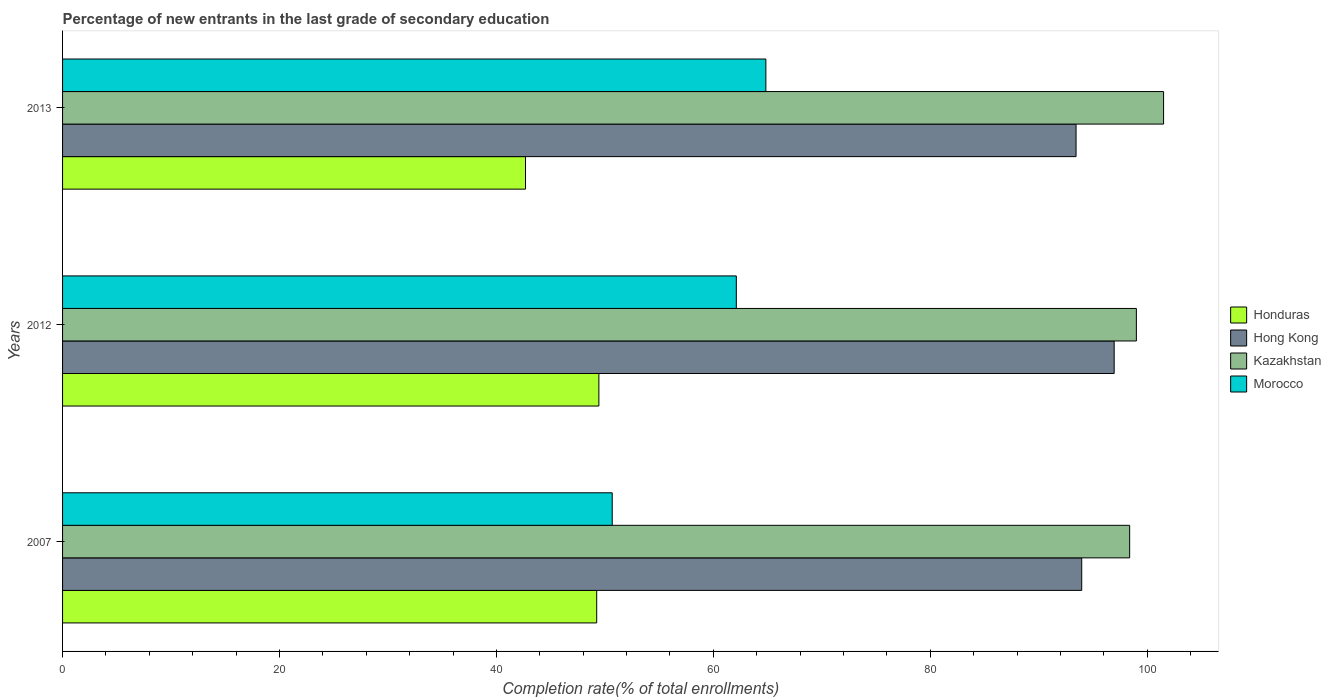How many groups of bars are there?
Your answer should be compact. 3. How many bars are there on the 3rd tick from the top?
Ensure brevity in your answer.  4. How many bars are there on the 1st tick from the bottom?
Your response must be concise. 4. In how many cases, is the number of bars for a given year not equal to the number of legend labels?
Your answer should be very brief. 0. What is the percentage of new entrants in Honduras in 2012?
Offer a terse response. 49.45. Across all years, what is the maximum percentage of new entrants in Hong Kong?
Give a very brief answer. 96.95. Across all years, what is the minimum percentage of new entrants in Morocco?
Ensure brevity in your answer.  50.67. In which year was the percentage of new entrants in Honduras maximum?
Provide a succinct answer. 2012. In which year was the percentage of new entrants in Honduras minimum?
Provide a short and direct response. 2013. What is the total percentage of new entrants in Kazakhstan in the graph?
Provide a succinct answer. 298.89. What is the difference between the percentage of new entrants in Honduras in 2007 and that in 2013?
Your answer should be compact. 6.56. What is the difference between the percentage of new entrants in Morocco in 2013 and the percentage of new entrants in Hong Kong in 2012?
Your response must be concise. -32.11. What is the average percentage of new entrants in Morocco per year?
Your response must be concise. 59.21. In the year 2012, what is the difference between the percentage of new entrants in Honduras and percentage of new entrants in Hong Kong?
Make the answer very short. -47.51. In how many years, is the percentage of new entrants in Morocco greater than 84 %?
Provide a short and direct response. 0. What is the ratio of the percentage of new entrants in Honduras in 2007 to that in 2013?
Give a very brief answer. 1.15. Is the difference between the percentage of new entrants in Honduras in 2012 and 2013 greater than the difference between the percentage of new entrants in Hong Kong in 2012 and 2013?
Ensure brevity in your answer.  Yes. What is the difference between the highest and the second highest percentage of new entrants in Hong Kong?
Provide a short and direct response. 2.99. What is the difference between the highest and the lowest percentage of new entrants in Honduras?
Make the answer very short. 6.77. In how many years, is the percentage of new entrants in Morocco greater than the average percentage of new entrants in Morocco taken over all years?
Ensure brevity in your answer.  2. Is the sum of the percentage of new entrants in Hong Kong in 2007 and 2013 greater than the maximum percentage of new entrants in Honduras across all years?
Keep it short and to the point. Yes. What does the 1st bar from the top in 2013 represents?
Your response must be concise. Morocco. What does the 4th bar from the bottom in 2013 represents?
Keep it short and to the point. Morocco. Is it the case that in every year, the sum of the percentage of new entrants in Hong Kong and percentage of new entrants in Morocco is greater than the percentage of new entrants in Honduras?
Offer a very short reply. Yes. How many years are there in the graph?
Your response must be concise. 3. What is the difference between two consecutive major ticks on the X-axis?
Provide a succinct answer. 20. Are the values on the major ticks of X-axis written in scientific E-notation?
Provide a short and direct response. No. Does the graph contain any zero values?
Provide a succinct answer. No. Where does the legend appear in the graph?
Offer a very short reply. Center right. How many legend labels are there?
Make the answer very short. 4. How are the legend labels stacked?
Your answer should be very brief. Vertical. What is the title of the graph?
Provide a succinct answer. Percentage of new entrants in the last grade of secondary education. What is the label or title of the X-axis?
Ensure brevity in your answer.  Completion rate(% of total enrollments). What is the label or title of the Y-axis?
Keep it short and to the point. Years. What is the Completion rate(% of total enrollments) in Honduras in 2007?
Offer a terse response. 49.24. What is the Completion rate(% of total enrollments) of Hong Kong in 2007?
Your response must be concise. 93.96. What is the Completion rate(% of total enrollments) in Kazakhstan in 2007?
Your response must be concise. 98.38. What is the Completion rate(% of total enrollments) of Morocco in 2007?
Your response must be concise. 50.67. What is the Completion rate(% of total enrollments) of Honduras in 2012?
Offer a terse response. 49.45. What is the Completion rate(% of total enrollments) in Hong Kong in 2012?
Provide a succinct answer. 96.95. What is the Completion rate(% of total enrollments) of Kazakhstan in 2012?
Offer a terse response. 99. What is the Completion rate(% of total enrollments) of Morocco in 2012?
Keep it short and to the point. 62.12. What is the Completion rate(% of total enrollments) in Honduras in 2013?
Offer a very short reply. 42.68. What is the Completion rate(% of total enrollments) of Hong Kong in 2013?
Provide a succinct answer. 93.44. What is the Completion rate(% of total enrollments) of Kazakhstan in 2013?
Make the answer very short. 101.51. What is the Completion rate(% of total enrollments) of Morocco in 2013?
Offer a very short reply. 64.84. Across all years, what is the maximum Completion rate(% of total enrollments) in Honduras?
Your response must be concise. 49.45. Across all years, what is the maximum Completion rate(% of total enrollments) in Hong Kong?
Make the answer very short. 96.95. Across all years, what is the maximum Completion rate(% of total enrollments) of Kazakhstan?
Provide a succinct answer. 101.51. Across all years, what is the maximum Completion rate(% of total enrollments) of Morocco?
Keep it short and to the point. 64.84. Across all years, what is the minimum Completion rate(% of total enrollments) in Honduras?
Offer a terse response. 42.68. Across all years, what is the minimum Completion rate(% of total enrollments) of Hong Kong?
Offer a very short reply. 93.44. Across all years, what is the minimum Completion rate(% of total enrollments) of Kazakhstan?
Give a very brief answer. 98.38. Across all years, what is the minimum Completion rate(% of total enrollments) in Morocco?
Offer a terse response. 50.67. What is the total Completion rate(% of total enrollments) of Honduras in the graph?
Your answer should be compact. 141.37. What is the total Completion rate(% of total enrollments) of Hong Kong in the graph?
Ensure brevity in your answer.  284.35. What is the total Completion rate(% of total enrollments) in Kazakhstan in the graph?
Give a very brief answer. 298.89. What is the total Completion rate(% of total enrollments) of Morocco in the graph?
Your answer should be compact. 177.63. What is the difference between the Completion rate(% of total enrollments) in Honduras in 2007 and that in 2012?
Give a very brief answer. -0.2. What is the difference between the Completion rate(% of total enrollments) in Hong Kong in 2007 and that in 2012?
Provide a short and direct response. -2.99. What is the difference between the Completion rate(% of total enrollments) of Kazakhstan in 2007 and that in 2012?
Make the answer very short. -0.62. What is the difference between the Completion rate(% of total enrollments) in Morocco in 2007 and that in 2012?
Offer a terse response. -11.44. What is the difference between the Completion rate(% of total enrollments) in Honduras in 2007 and that in 2013?
Your response must be concise. 6.56. What is the difference between the Completion rate(% of total enrollments) in Hong Kong in 2007 and that in 2013?
Your answer should be compact. 0.52. What is the difference between the Completion rate(% of total enrollments) of Kazakhstan in 2007 and that in 2013?
Your response must be concise. -3.13. What is the difference between the Completion rate(% of total enrollments) of Morocco in 2007 and that in 2013?
Offer a terse response. -14.17. What is the difference between the Completion rate(% of total enrollments) in Honduras in 2012 and that in 2013?
Your answer should be compact. 6.77. What is the difference between the Completion rate(% of total enrollments) in Hong Kong in 2012 and that in 2013?
Ensure brevity in your answer.  3.51. What is the difference between the Completion rate(% of total enrollments) in Kazakhstan in 2012 and that in 2013?
Your response must be concise. -2.51. What is the difference between the Completion rate(% of total enrollments) of Morocco in 2012 and that in 2013?
Make the answer very short. -2.73. What is the difference between the Completion rate(% of total enrollments) in Honduras in 2007 and the Completion rate(% of total enrollments) in Hong Kong in 2012?
Keep it short and to the point. -47.71. What is the difference between the Completion rate(% of total enrollments) of Honduras in 2007 and the Completion rate(% of total enrollments) of Kazakhstan in 2012?
Your answer should be very brief. -49.76. What is the difference between the Completion rate(% of total enrollments) in Honduras in 2007 and the Completion rate(% of total enrollments) in Morocco in 2012?
Your answer should be very brief. -12.87. What is the difference between the Completion rate(% of total enrollments) of Hong Kong in 2007 and the Completion rate(% of total enrollments) of Kazakhstan in 2012?
Ensure brevity in your answer.  -5.04. What is the difference between the Completion rate(% of total enrollments) of Hong Kong in 2007 and the Completion rate(% of total enrollments) of Morocco in 2012?
Offer a terse response. 31.84. What is the difference between the Completion rate(% of total enrollments) of Kazakhstan in 2007 and the Completion rate(% of total enrollments) of Morocco in 2012?
Provide a short and direct response. 36.26. What is the difference between the Completion rate(% of total enrollments) of Honduras in 2007 and the Completion rate(% of total enrollments) of Hong Kong in 2013?
Offer a very short reply. -44.19. What is the difference between the Completion rate(% of total enrollments) in Honduras in 2007 and the Completion rate(% of total enrollments) in Kazakhstan in 2013?
Provide a short and direct response. -52.26. What is the difference between the Completion rate(% of total enrollments) of Honduras in 2007 and the Completion rate(% of total enrollments) of Morocco in 2013?
Keep it short and to the point. -15.6. What is the difference between the Completion rate(% of total enrollments) of Hong Kong in 2007 and the Completion rate(% of total enrollments) of Kazakhstan in 2013?
Your response must be concise. -7.55. What is the difference between the Completion rate(% of total enrollments) in Hong Kong in 2007 and the Completion rate(% of total enrollments) in Morocco in 2013?
Give a very brief answer. 29.12. What is the difference between the Completion rate(% of total enrollments) in Kazakhstan in 2007 and the Completion rate(% of total enrollments) in Morocco in 2013?
Your answer should be compact. 33.54. What is the difference between the Completion rate(% of total enrollments) of Honduras in 2012 and the Completion rate(% of total enrollments) of Hong Kong in 2013?
Provide a succinct answer. -43.99. What is the difference between the Completion rate(% of total enrollments) of Honduras in 2012 and the Completion rate(% of total enrollments) of Kazakhstan in 2013?
Your response must be concise. -52.06. What is the difference between the Completion rate(% of total enrollments) in Honduras in 2012 and the Completion rate(% of total enrollments) in Morocco in 2013?
Offer a very short reply. -15.4. What is the difference between the Completion rate(% of total enrollments) in Hong Kong in 2012 and the Completion rate(% of total enrollments) in Kazakhstan in 2013?
Ensure brevity in your answer.  -4.56. What is the difference between the Completion rate(% of total enrollments) in Hong Kong in 2012 and the Completion rate(% of total enrollments) in Morocco in 2013?
Your answer should be very brief. 32.11. What is the difference between the Completion rate(% of total enrollments) in Kazakhstan in 2012 and the Completion rate(% of total enrollments) in Morocco in 2013?
Offer a very short reply. 34.16. What is the average Completion rate(% of total enrollments) in Honduras per year?
Your answer should be very brief. 47.12. What is the average Completion rate(% of total enrollments) in Hong Kong per year?
Make the answer very short. 94.78. What is the average Completion rate(% of total enrollments) in Kazakhstan per year?
Provide a succinct answer. 99.63. What is the average Completion rate(% of total enrollments) of Morocco per year?
Give a very brief answer. 59.21. In the year 2007, what is the difference between the Completion rate(% of total enrollments) in Honduras and Completion rate(% of total enrollments) in Hong Kong?
Your response must be concise. -44.72. In the year 2007, what is the difference between the Completion rate(% of total enrollments) of Honduras and Completion rate(% of total enrollments) of Kazakhstan?
Your response must be concise. -49.14. In the year 2007, what is the difference between the Completion rate(% of total enrollments) of Honduras and Completion rate(% of total enrollments) of Morocco?
Make the answer very short. -1.43. In the year 2007, what is the difference between the Completion rate(% of total enrollments) of Hong Kong and Completion rate(% of total enrollments) of Kazakhstan?
Make the answer very short. -4.42. In the year 2007, what is the difference between the Completion rate(% of total enrollments) in Hong Kong and Completion rate(% of total enrollments) in Morocco?
Your answer should be very brief. 43.28. In the year 2007, what is the difference between the Completion rate(% of total enrollments) in Kazakhstan and Completion rate(% of total enrollments) in Morocco?
Offer a terse response. 47.71. In the year 2012, what is the difference between the Completion rate(% of total enrollments) in Honduras and Completion rate(% of total enrollments) in Hong Kong?
Make the answer very short. -47.51. In the year 2012, what is the difference between the Completion rate(% of total enrollments) in Honduras and Completion rate(% of total enrollments) in Kazakhstan?
Your response must be concise. -49.55. In the year 2012, what is the difference between the Completion rate(% of total enrollments) of Honduras and Completion rate(% of total enrollments) of Morocco?
Provide a short and direct response. -12.67. In the year 2012, what is the difference between the Completion rate(% of total enrollments) in Hong Kong and Completion rate(% of total enrollments) in Kazakhstan?
Your answer should be very brief. -2.05. In the year 2012, what is the difference between the Completion rate(% of total enrollments) of Hong Kong and Completion rate(% of total enrollments) of Morocco?
Ensure brevity in your answer.  34.84. In the year 2012, what is the difference between the Completion rate(% of total enrollments) of Kazakhstan and Completion rate(% of total enrollments) of Morocco?
Your answer should be compact. 36.88. In the year 2013, what is the difference between the Completion rate(% of total enrollments) in Honduras and Completion rate(% of total enrollments) in Hong Kong?
Offer a terse response. -50.76. In the year 2013, what is the difference between the Completion rate(% of total enrollments) in Honduras and Completion rate(% of total enrollments) in Kazakhstan?
Your answer should be compact. -58.83. In the year 2013, what is the difference between the Completion rate(% of total enrollments) in Honduras and Completion rate(% of total enrollments) in Morocco?
Offer a terse response. -22.16. In the year 2013, what is the difference between the Completion rate(% of total enrollments) in Hong Kong and Completion rate(% of total enrollments) in Kazakhstan?
Ensure brevity in your answer.  -8.07. In the year 2013, what is the difference between the Completion rate(% of total enrollments) in Hong Kong and Completion rate(% of total enrollments) in Morocco?
Give a very brief answer. 28.6. In the year 2013, what is the difference between the Completion rate(% of total enrollments) of Kazakhstan and Completion rate(% of total enrollments) of Morocco?
Provide a short and direct response. 36.67. What is the ratio of the Completion rate(% of total enrollments) in Hong Kong in 2007 to that in 2012?
Ensure brevity in your answer.  0.97. What is the ratio of the Completion rate(% of total enrollments) of Kazakhstan in 2007 to that in 2012?
Your response must be concise. 0.99. What is the ratio of the Completion rate(% of total enrollments) of Morocco in 2007 to that in 2012?
Your answer should be compact. 0.82. What is the ratio of the Completion rate(% of total enrollments) in Honduras in 2007 to that in 2013?
Ensure brevity in your answer.  1.15. What is the ratio of the Completion rate(% of total enrollments) in Hong Kong in 2007 to that in 2013?
Give a very brief answer. 1.01. What is the ratio of the Completion rate(% of total enrollments) in Kazakhstan in 2007 to that in 2013?
Offer a very short reply. 0.97. What is the ratio of the Completion rate(% of total enrollments) of Morocco in 2007 to that in 2013?
Make the answer very short. 0.78. What is the ratio of the Completion rate(% of total enrollments) in Honduras in 2012 to that in 2013?
Keep it short and to the point. 1.16. What is the ratio of the Completion rate(% of total enrollments) of Hong Kong in 2012 to that in 2013?
Offer a terse response. 1.04. What is the ratio of the Completion rate(% of total enrollments) in Kazakhstan in 2012 to that in 2013?
Provide a short and direct response. 0.98. What is the ratio of the Completion rate(% of total enrollments) in Morocco in 2012 to that in 2013?
Provide a succinct answer. 0.96. What is the difference between the highest and the second highest Completion rate(% of total enrollments) in Honduras?
Make the answer very short. 0.2. What is the difference between the highest and the second highest Completion rate(% of total enrollments) of Hong Kong?
Provide a succinct answer. 2.99. What is the difference between the highest and the second highest Completion rate(% of total enrollments) in Kazakhstan?
Offer a very short reply. 2.51. What is the difference between the highest and the second highest Completion rate(% of total enrollments) of Morocco?
Your answer should be compact. 2.73. What is the difference between the highest and the lowest Completion rate(% of total enrollments) of Honduras?
Provide a short and direct response. 6.77. What is the difference between the highest and the lowest Completion rate(% of total enrollments) of Hong Kong?
Give a very brief answer. 3.51. What is the difference between the highest and the lowest Completion rate(% of total enrollments) of Kazakhstan?
Your answer should be compact. 3.13. What is the difference between the highest and the lowest Completion rate(% of total enrollments) of Morocco?
Provide a succinct answer. 14.17. 